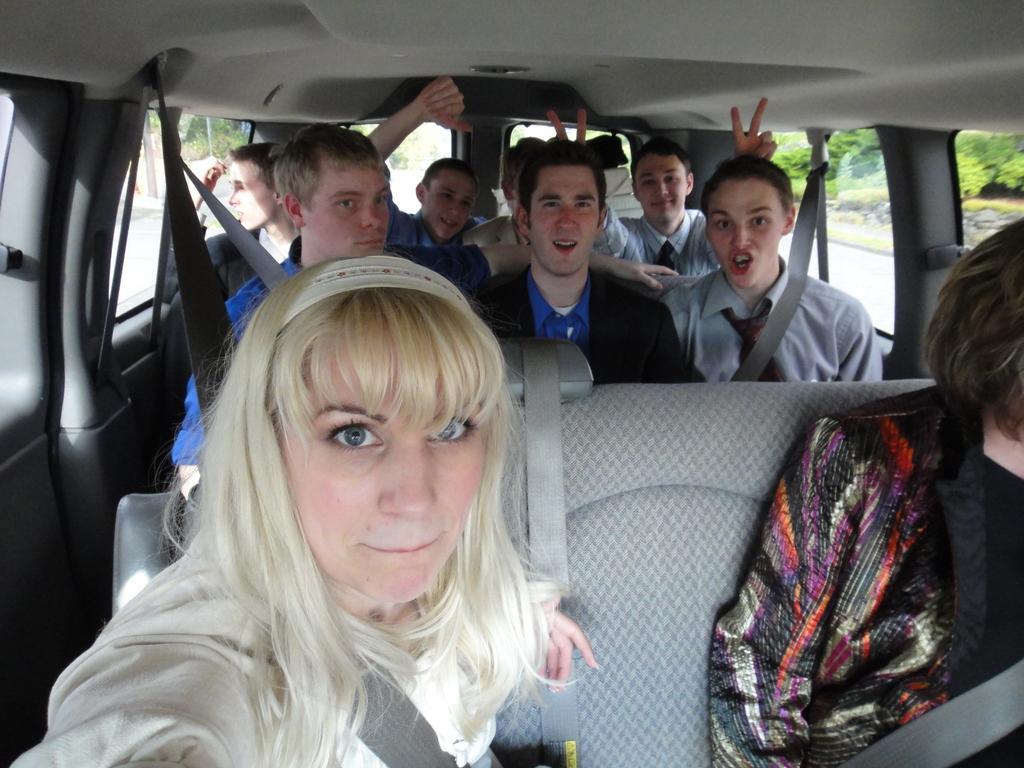Can you describe this image briefly? In the image we can see there are people who are sitting in a car. 